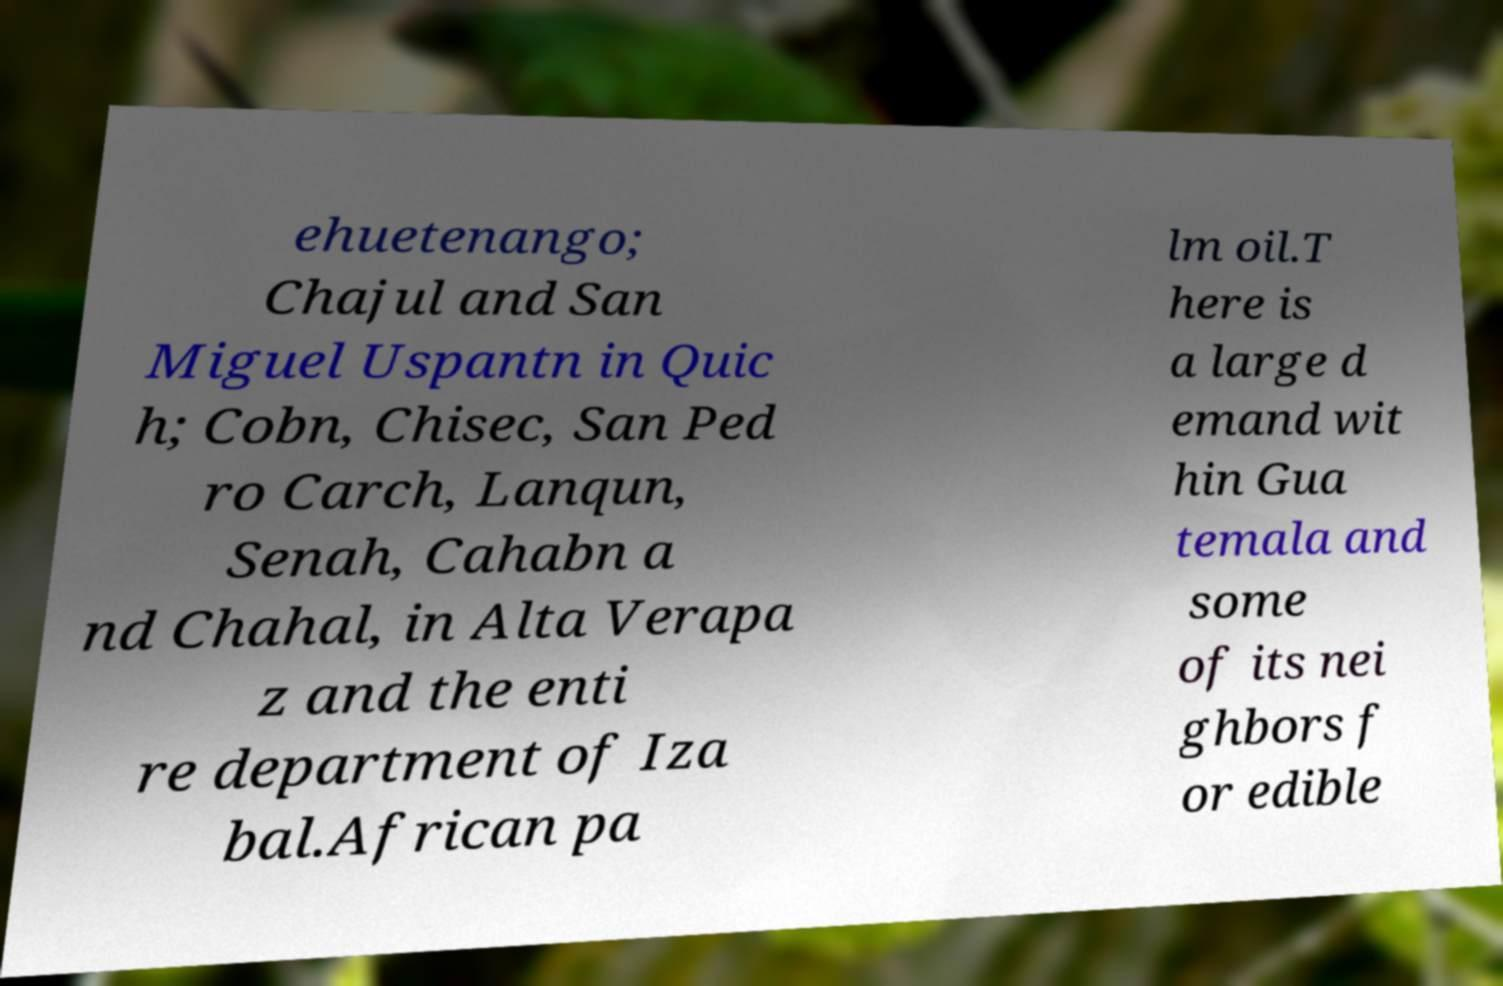Please identify and transcribe the text found in this image. ehuetenango; Chajul and San Miguel Uspantn in Quic h; Cobn, Chisec, San Ped ro Carch, Lanqun, Senah, Cahabn a nd Chahal, in Alta Verapa z and the enti re department of Iza bal.African pa lm oil.T here is a large d emand wit hin Gua temala and some of its nei ghbors f or edible 